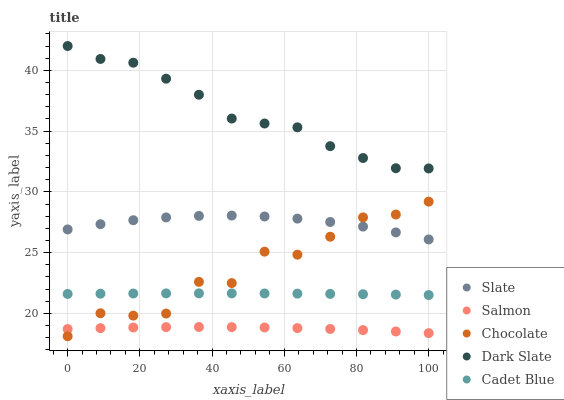Does Salmon have the minimum area under the curve?
Answer yes or no. Yes. Does Dark Slate have the maximum area under the curve?
Answer yes or no. Yes. Does Slate have the minimum area under the curve?
Answer yes or no. No. Does Slate have the maximum area under the curve?
Answer yes or no. No. Is Cadet Blue the smoothest?
Answer yes or no. Yes. Is Chocolate the roughest?
Answer yes or no. Yes. Is Slate the smoothest?
Answer yes or no. No. Is Slate the roughest?
Answer yes or no. No. Does Chocolate have the lowest value?
Answer yes or no. Yes. Does Slate have the lowest value?
Answer yes or no. No. Does Dark Slate have the highest value?
Answer yes or no. Yes. Does Slate have the highest value?
Answer yes or no. No. Is Cadet Blue less than Slate?
Answer yes or no. Yes. Is Dark Slate greater than Cadet Blue?
Answer yes or no. Yes. Does Cadet Blue intersect Chocolate?
Answer yes or no. Yes. Is Cadet Blue less than Chocolate?
Answer yes or no. No. Is Cadet Blue greater than Chocolate?
Answer yes or no. No. Does Cadet Blue intersect Slate?
Answer yes or no. No. 